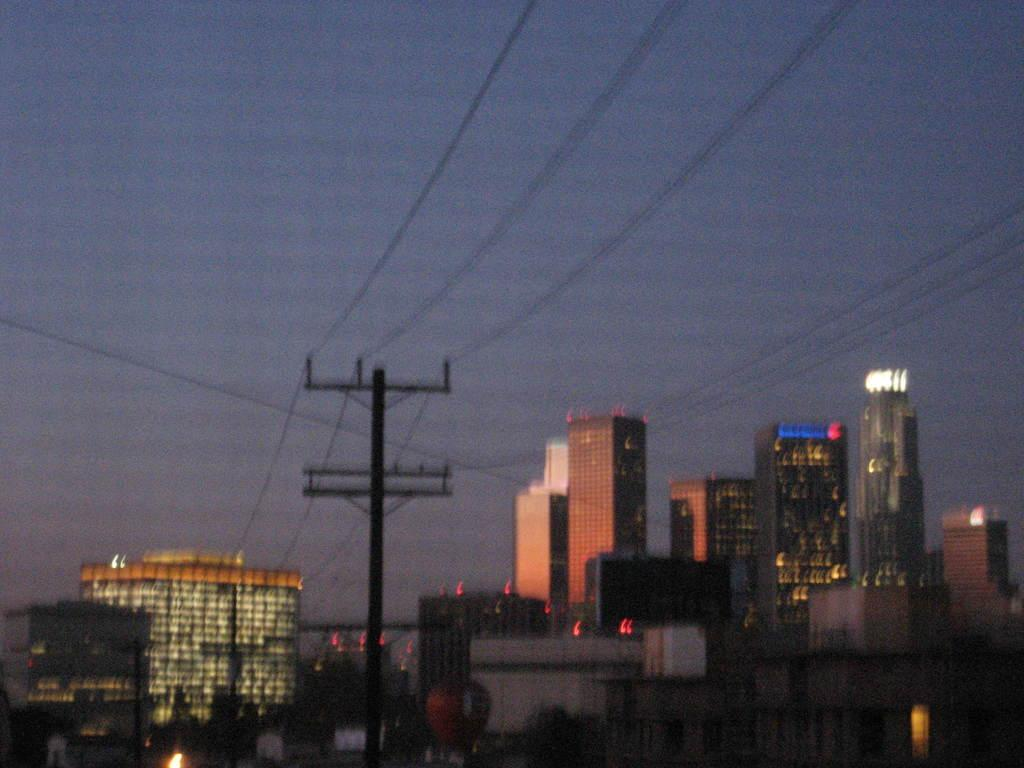What type of structures are illuminated in the image? There are buildings with lights in the image. What additional information is displayed in the image? There are current polls in the image. What can be seen in the background of the image? The sky is visible in the image. Can you tell me how many kitties are playing in space in the image? There are no kitties or space depicted in the image; it features buildings with lights and current polls. 